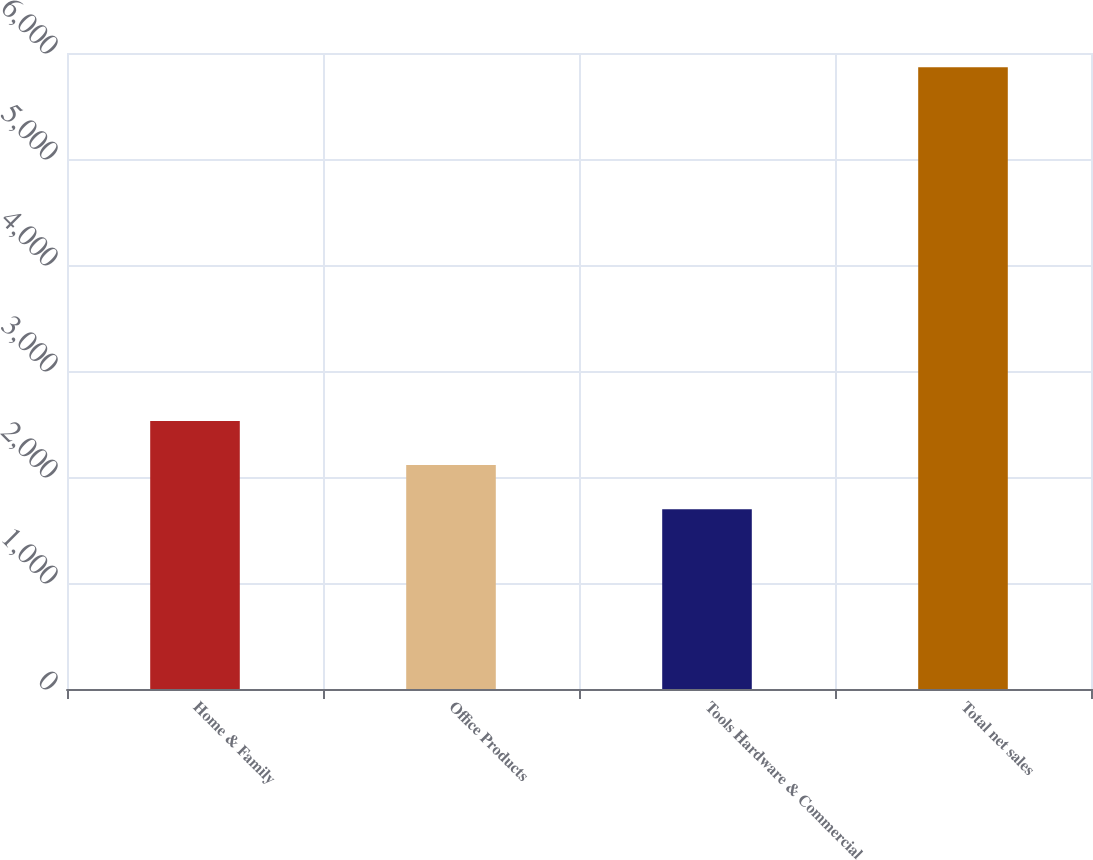<chart> <loc_0><loc_0><loc_500><loc_500><bar_chart><fcel>Home & Family<fcel>Office Products<fcel>Tools Hardware & Commercial<fcel>Total net sales<nl><fcel>2529.16<fcel>2112.23<fcel>1695.3<fcel>5864.6<nl></chart> 